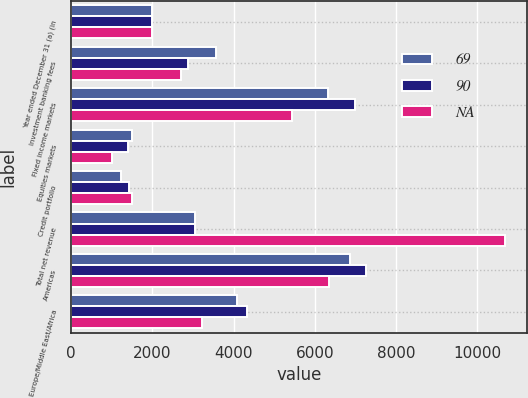Convert chart. <chart><loc_0><loc_0><loc_500><loc_500><stacked_bar_chart><ecel><fcel>Year ended December 31 (a) (in<fcel>Investment banking fees<fcel>Fixed income markets<fcel>Equities markets<fcel>Credit portfolio<fcel>Total net revenue<fcel>Americas<fcel>Europe/Middle East/Africa<nl><fcel>69<fcel>2004<fcel>3572<fcel>6314<fcel>1491<fcel>1228<fcel>3043<fcel>6870<fcel>4082<nl><fcel>90<fcel>2003<fcel>2871<fcel>6987<fcel>1406<fcel>1420<fcel>3043<fcel>7250<fcel>4331<nl><fcel>nan<fcel>2002<fcel>2707<fcel>5450<fcel>1018<fcel>1507<fcel>10682<fcel>6360<fcel>3215<nl></chart> 